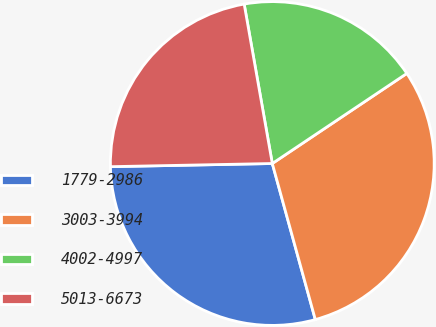Convert chart to OTSL. <chart><loc_0><loc_0><loc_500><loc_500><pie_chart><fcel>1779-2986<fcel>3003-3994<fcel>4002-4997<fcel>5013-6673<nl><fcel>28.97%<fcel>30.11%<fcel>18.39%<fcel>22.53%<nl></chart> 